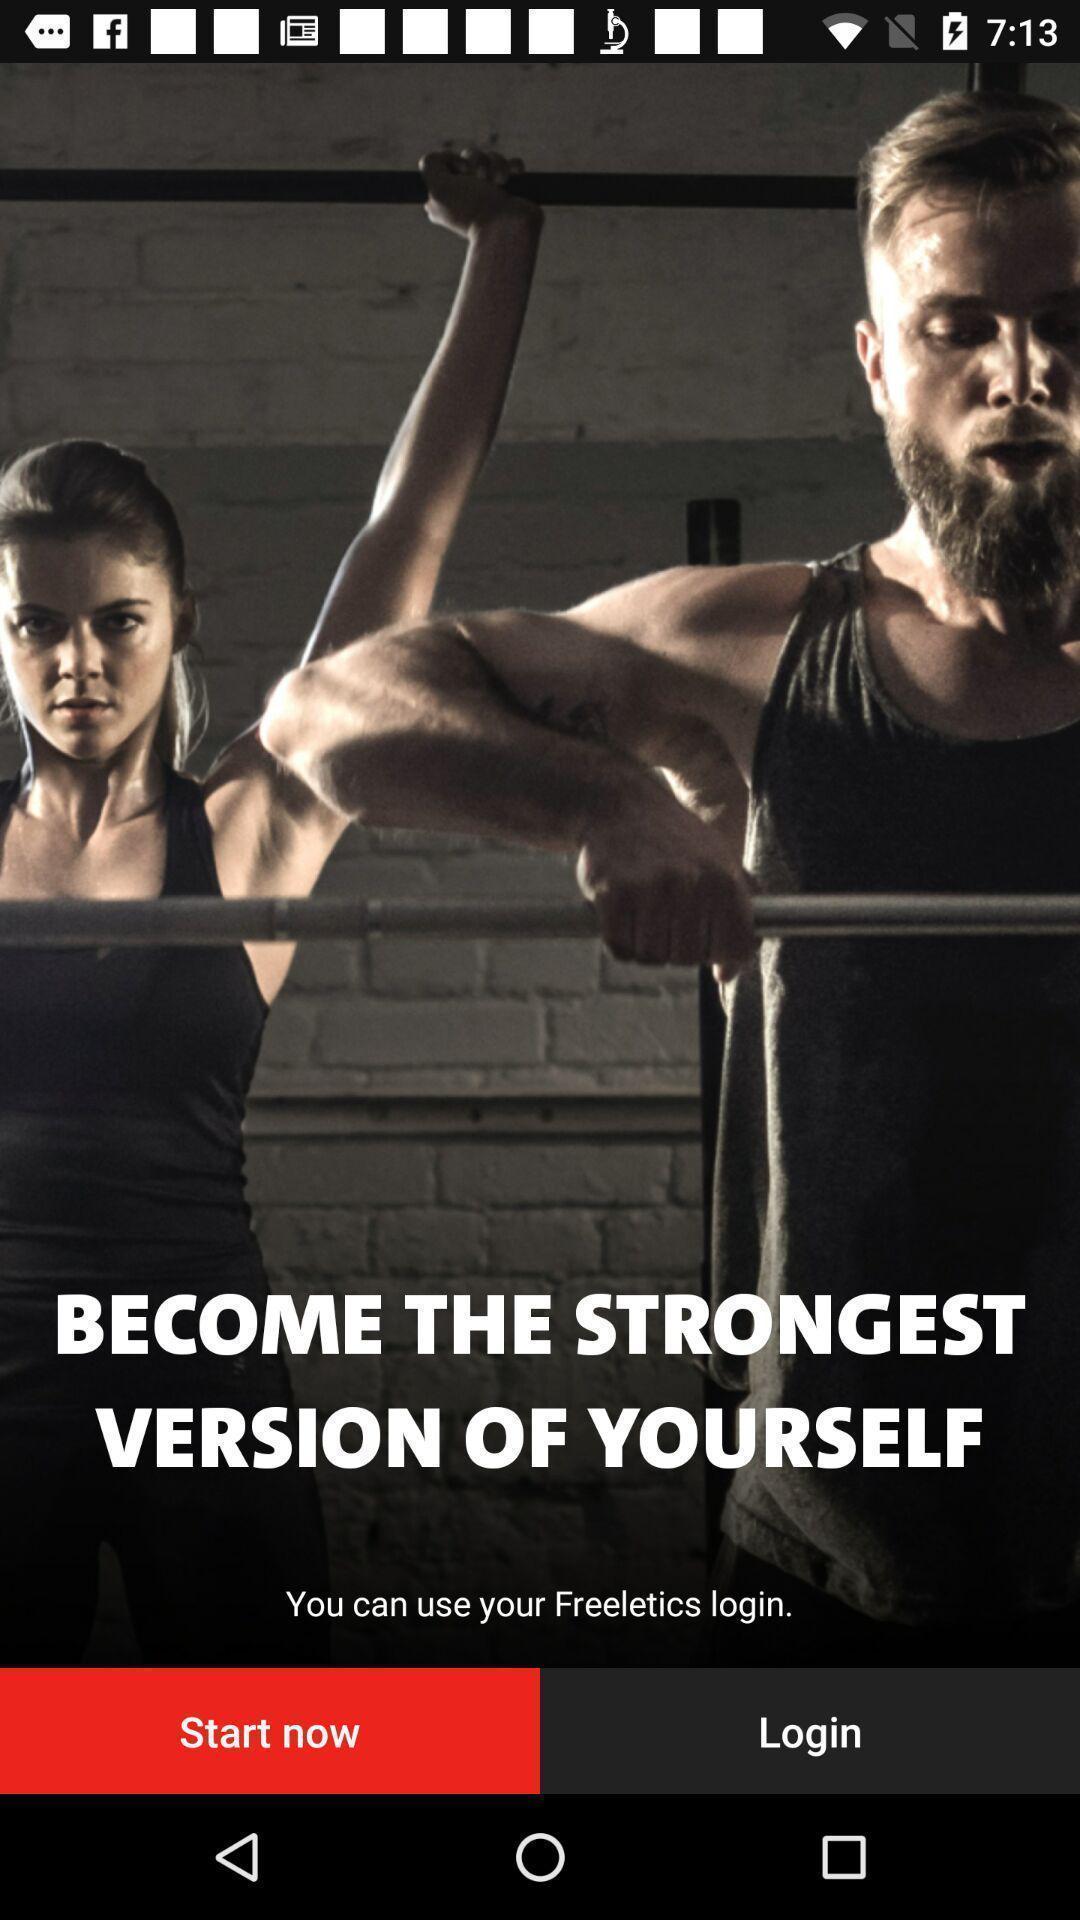Summarize the main components in this picture. Screen displaying login page of a fitness application. 